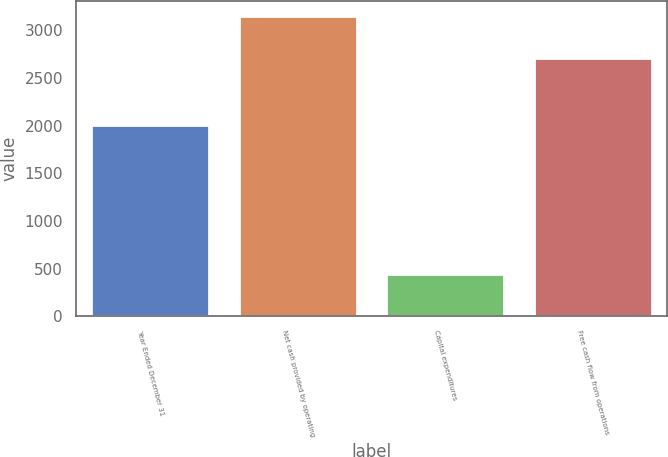<chart> <loc_0><loc_0><loc_500><loc_500><bar_chart><fcel>Year Ended December 31<fcel>Net cash provided by operating<fcel>Capital expenditures<fcel>Free cash flow from operations<nl><fcel>2011<fcel>3150<fcel>445<fcel>2705<nl></chart> 